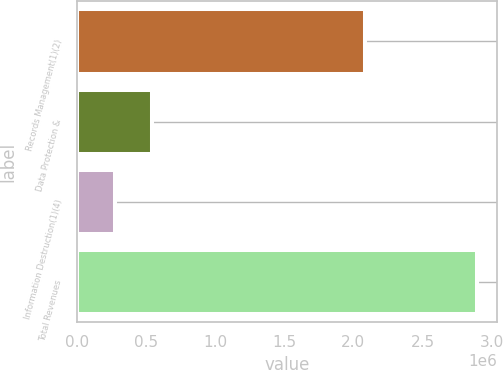<chart> <loc_0><loc_0><loc_500><loc_500><bar_chart><fcel>Records Management(1)(2)<fcel>Data Protection &<fcel>Information Destruction(1)(4)<fcel>Total Revenues<nl><fcel>2.08149e+06<fcel>540584<fcel>279277<fcel>2.89235e+06<nl></chart> 